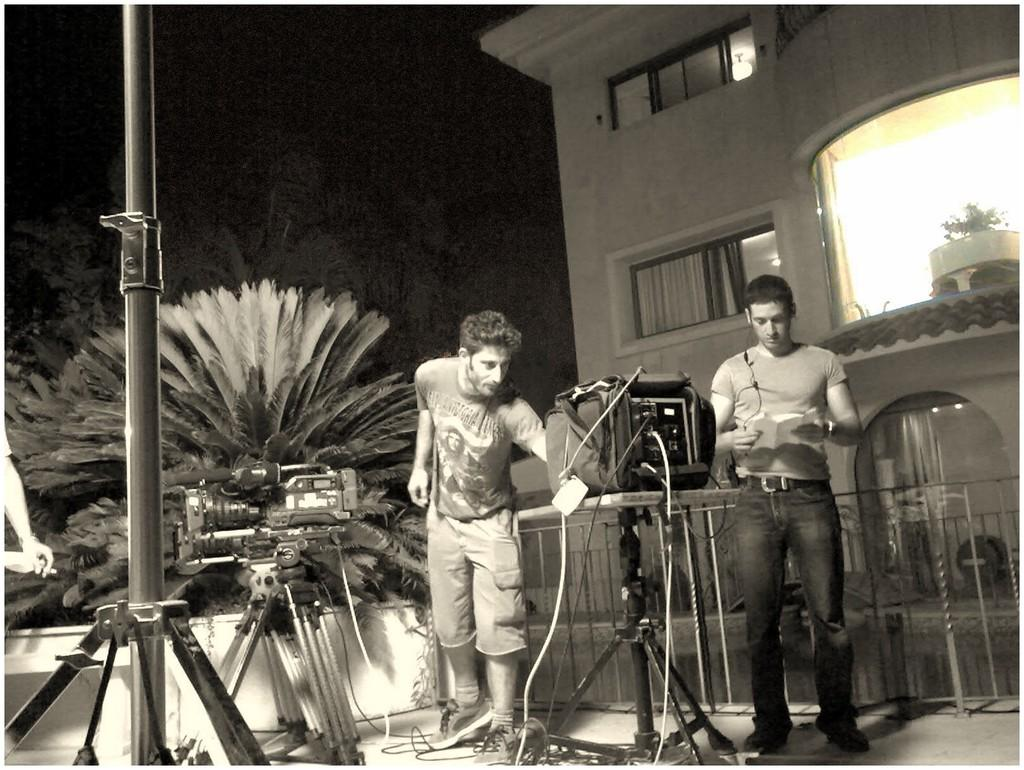What is the color scheme of the image? The image is black and white. What can be seen in the middle of the image? A man is standing in the middle of the image. What is the man wearing? The man is wearing a t-shirt and shorts. What is located on the right side of the image? There is a building on the right side of the image. What type of vegetation is on the left side of the image? There are trees on the left side of the image. What type of thrill can be seen in the image? There is no thrill present in the image; it features a man standing in the middle of a black and white scene with a building and trees in the background. Can you spot a scarecrow in the image? There is no scarecrow present in the image. 